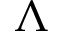<formula> <loc_0><loc_0><loc_500><loc_500>\Lambda</formula> 